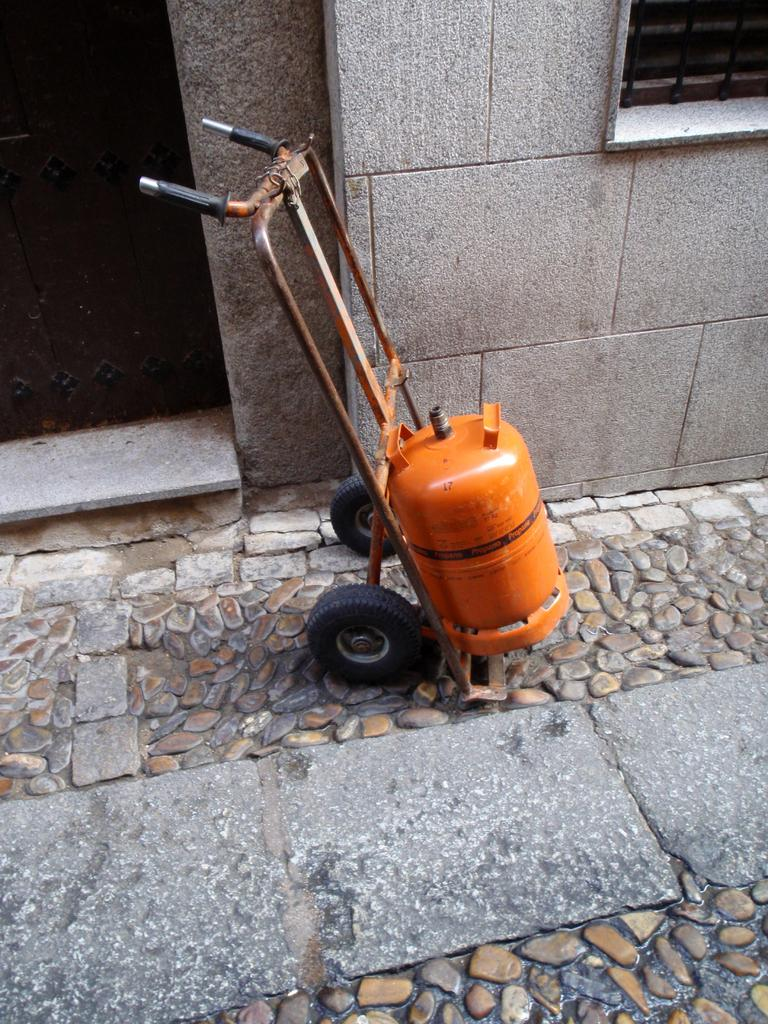What object in the image resembles a trolley? There is an object in the image that resembles a trolley. What is on the trolley? The trolley has an orange-colored cylinder on it. What is behind the trolley in the image? There is a wall behind the trolley. What features are present on the wall? The wall contains a door and a window. What type of lamp is hanging from the ceiling in the image? There is no lamp hanging from the ceiling in the image; it only features a trolley, a wall, and the wall's features. How many berries are visible on the trolley in the image? There are no berries present in the image; it only features a trolley with an orange-colored cylinder. 